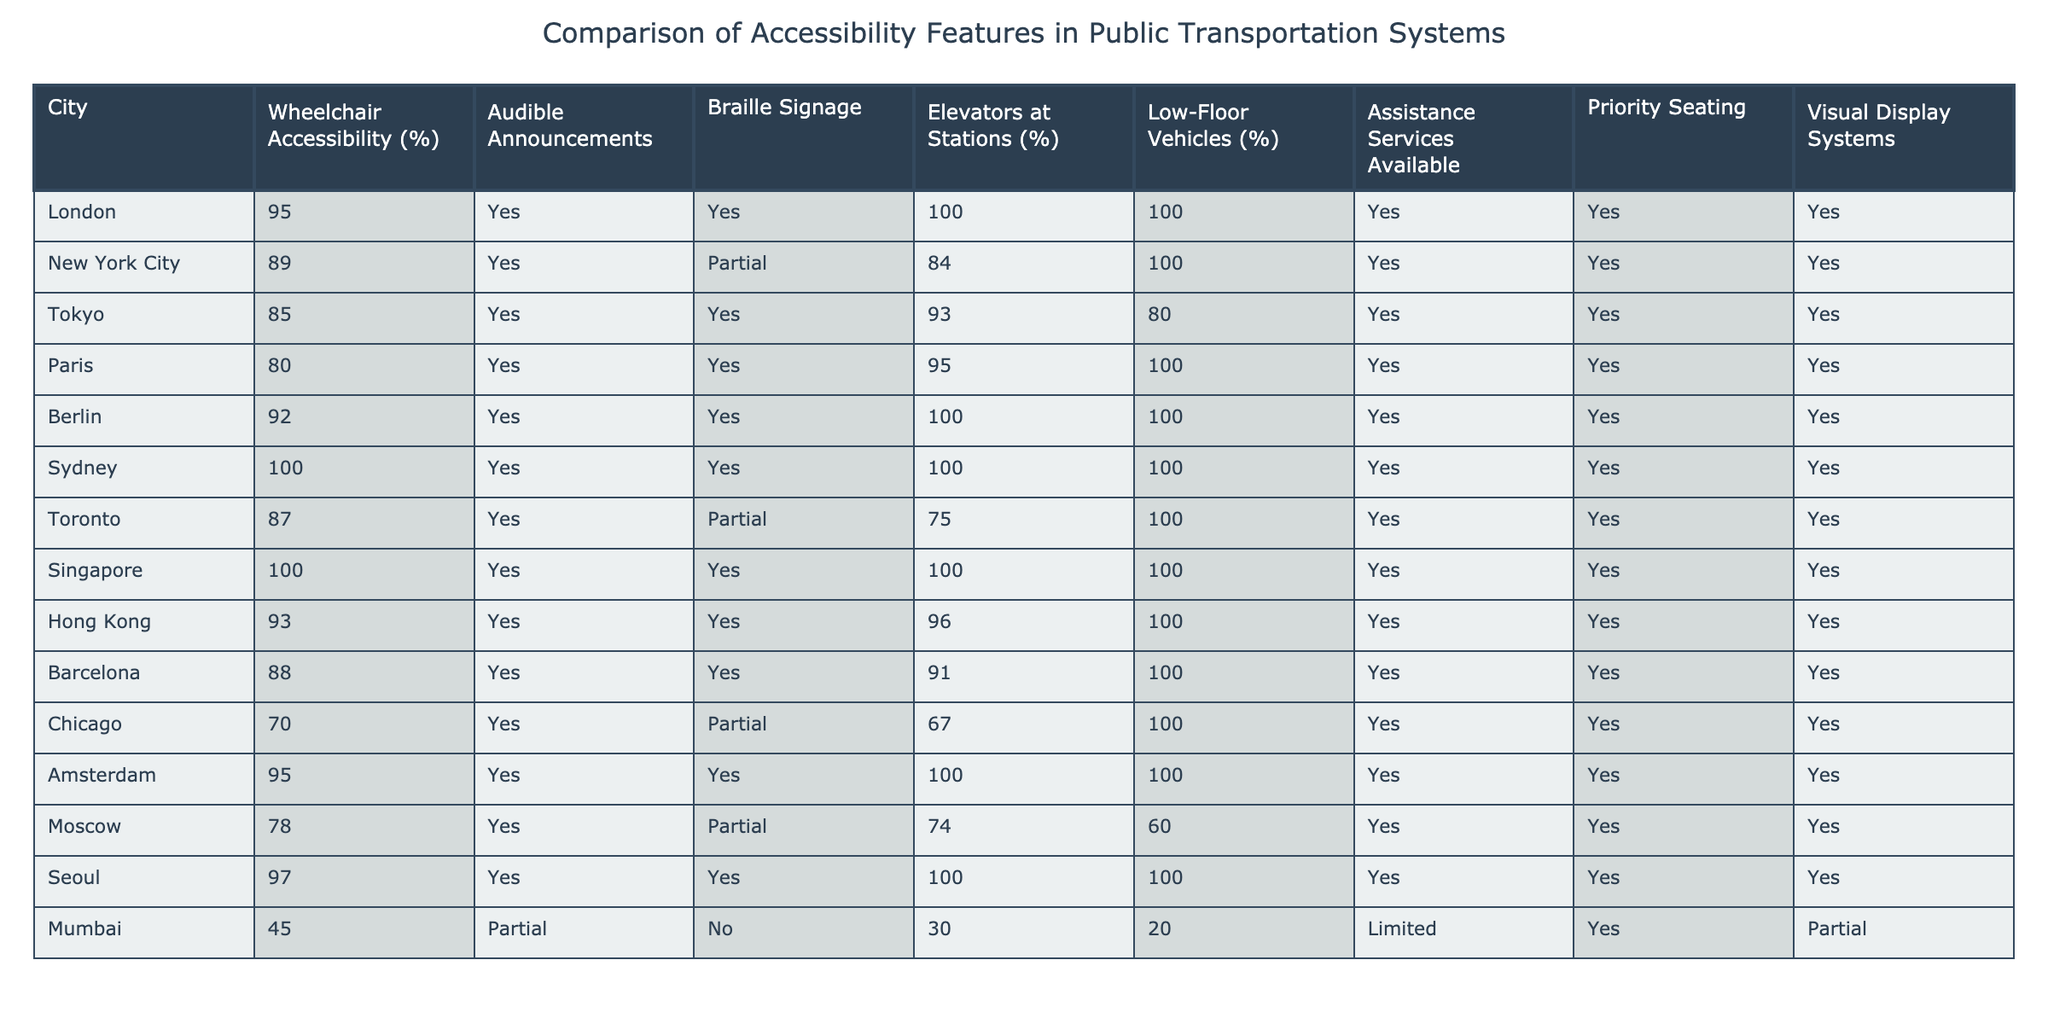What percentage of wheelchair accessibility is in Sydney? The table shows that Sydney has a wheelchair accessibility percentage of 100%.
Answer: 100% What cities have the highest percentage of elevator availability at stations? Looking at the table, both Sydney and Berlin have 100% availability of elevators at stations.
Answer: Sydney and Berlin Which city has the lowest percentage of wheelchair accessibility? By examining the table, Mumbai has the lowest wheelchair accessibility percentage, which is 45%.
Answer: 45% Is audible announcement a feature available in all listed cities? The table indicates that all cities marked 'Yes' for audible announcements, confirming that this feature is universally available.
Answer: Yes How many cities have both Braille signage and elevators at stations? By cross-referencing the table, it can be seen that 11 out of 12 cities have both Braille signage and elevators at stations.
Answer: 11 What is the average percentage of low-floor vehicles among the cities? To find the average, sum the low-floor vehicle percentages (100 + 100 + 80 + 100 + 100 + 100 + 100 + 100 + 100 + 100 + 20) and divide by the number of cities (11). The total is 1100 and the average is approximately 100.
Answer: 100 Do any cities not provide assistance services? The data shows that Mumbai is the only city with 'Limited' assistance services, indicating some level of lack in comprehensive assistance.
Answer: Yes Which city has the best overall accessibility features based on wheelchair accessibility and elevator access? Both Sydney and Singapore are tied with 100% for wheelchair accessibility and elevator availability at stations, making them the top cities for overall accessibility features.
Answer: Sydney and Singapore What is the difference in wheelchair accessibility between New York City and Barcelona? New York City has 89% wheelchair accessibility and Barcelona has 88%. The difference is 1%.
Answer: 1% Which city has the lowest percentage of low-floor vehicles and what is that percentage? According to the table, Mumbai has the lowest percentage of low-floor vehicles at 20%.
Answer: 20% 